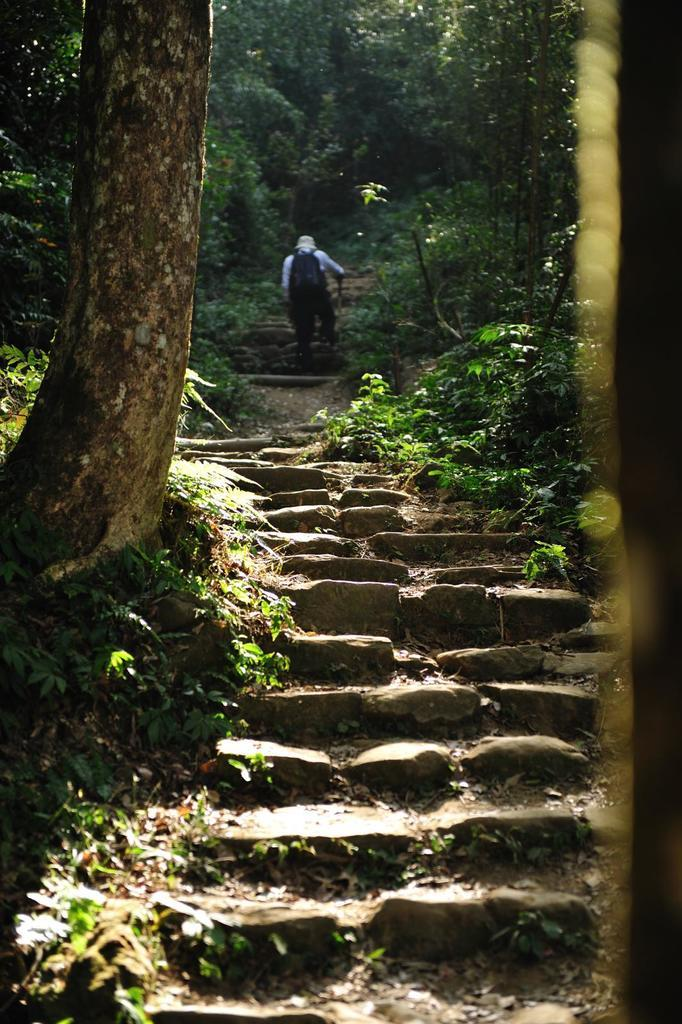What type of vegetation can be seen in the image? There are plants and trees in the image. Can you describe the person in the image? There is a person walking in the image. What type of trade is happening between the plants and trees in the image? There is no trade happening between the plants and trees in the image; they are simply growing in their natural environment. What amusement park can be seen in the background of the image? There is no amusement park present in the image; it features plants, trees, and a person walking. 